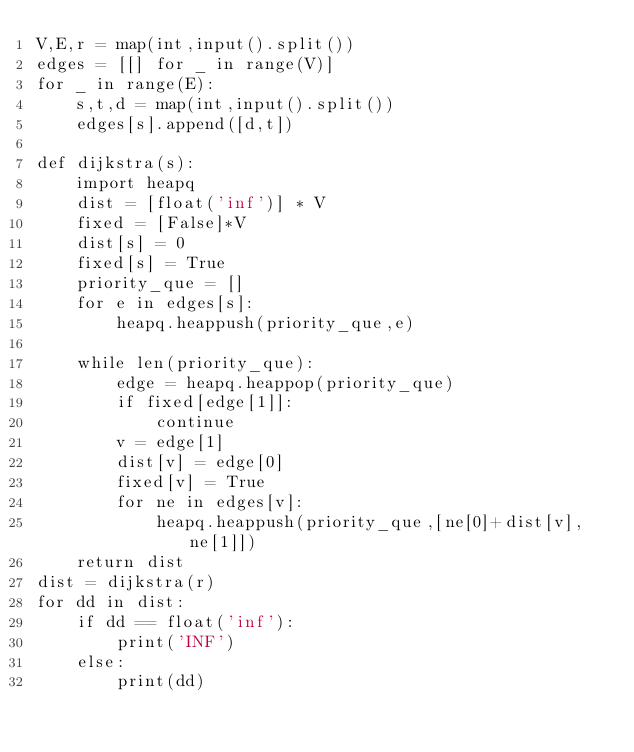Convert code to text. <code><loc_0><loc_0><loc_500><loc_500><_Python_>V,E,r = map(int,input().split())
edges = [[] for _ in range(V)]
for _ in range(E):
    s,t,d = map(int,input().split())
    edges[s].append([d,t])

def dijkstra(s):
    import heapq
    dist = [float('inf')] * V
    fixed = [False]*V
    dist[s] = 0
    fixed[s] = True
    priority_que = []
    for e in edges[s]:
        heapq.heappush(priority_que,e)

    while len(priority_que):
        edge = heapq.heappop(priority_que)
        if fixed[edge[1]]:
            continue
        v = edge[1]
        dist[v] = edge[0]
        fixed[v] = True
        for ne in edges[v]:
            heapq.heappush(priority_que,[ne[0]+dist[v], ne[1]])
    return dist
dist = dijkstra(r)
for dd in dist:
    if dd == float('inf'):
        print('INF')
    else:
        print(dd)

</code> 